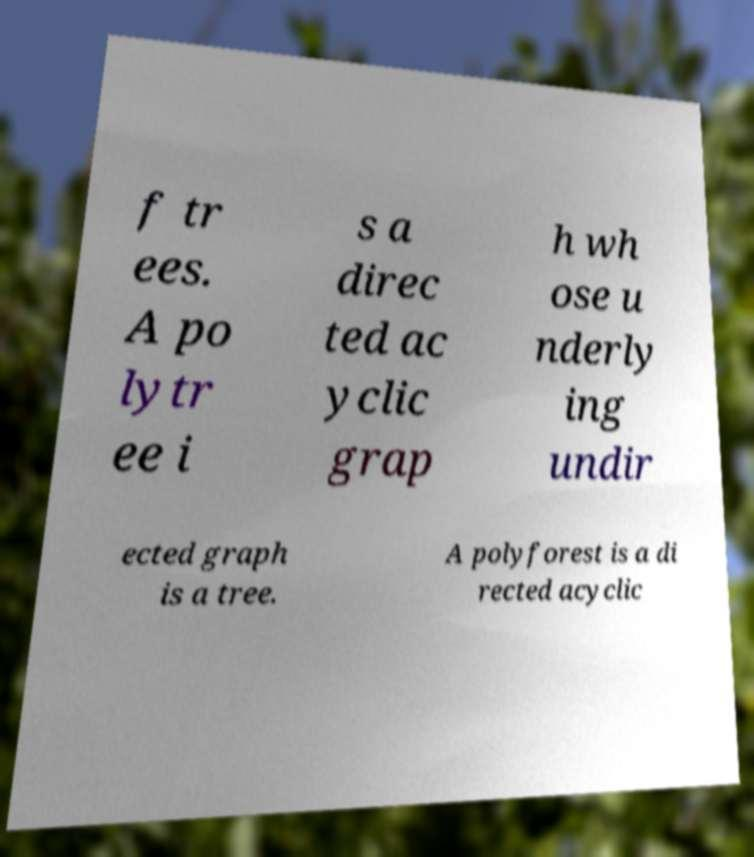Can you accurately transcribe the text from the provided image for me? f tr ees. A po lytr ee i s a direc ted ac yclic grap h wh ose u nderly ing undir ected graph is a tree. A polyforest is a di rected acyclic 